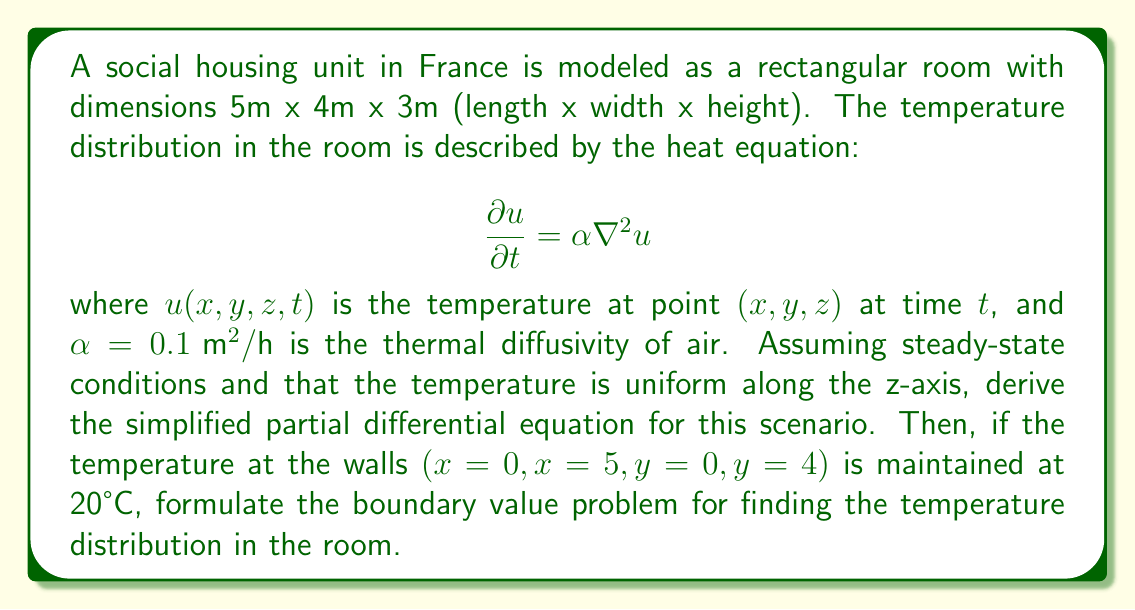What is the answer to this math problem? To solve this problem, we'll follow these steps:

1) First, we need to simplify the heat equation for steady-state conditions and uniform temperature along the z-axis.

   Steady-state means that the temperature doesn't change with time, so $\frac{\partial u}{\partial t} = 0$.

   The Laplacian operator $\nabla^2$ in 3D is:

   $$\nabla^2 u = \frac{\partial^2 u}{\partial x^2} + \frac{\partial^2 u}{\partial y^2} + \frac{\partial^2 u}{\partial z^2}$$

   Since the temperature is uniform along the z-axis, $\frac{\partial^2 u}{\partial z^2} = 0$.

2) Applying these conditions to the heat equation:

   $$0 = \alpha \left(\frac{\partial^2 u}{\partial x^2} + \frac{\partial^2 u}{\partial y^2}\right)$$

   Dividing both sides by $\alpha$ (which is non-zero):

   $$\frac{\partial^2 u}{\partial x^2} + \frac{\partial^2 u}{\partial y^2} = 0$$

   This is the simplified partial differential equation for our scenario.

3) Now, we need to formulate the boundary value problem. This involves stating the PDE and the boundary conditions.

   The PDE is:
   $$\frac{\partial^2 u}{\partial x^2} + \frac{\partial^2 u}{\partial y^2} = 0, \quad 0 < x < 5, \quad 0 < y < 4$$

   The boundary conditions are:
   $$u(0,y) = u(5,y) = u(x,0) = u(x,4) = 20, \quad 0 \leq x \leq 5, \quad 0 \leq y \leq 4$$

These equations together form the complete boundary value problem for finding the temperature distribution in the room.
Answer: The boundary value problem for the temperature distribution in the room is:

PDE: $$\frac{\partial^2 u}{\partial x^2} + \frac{\partial^2 u}{\partial y^2} = 0, \quad 0 < x < 5, \quad 0 < y < 4$$

Boundary Conditions: $$u(0,y) = u(5,y) = u(x,0) = u(x,4) = 20, \quad 0 \leq x \leq 5, \quad 0 \leq y \leq 4$$ 